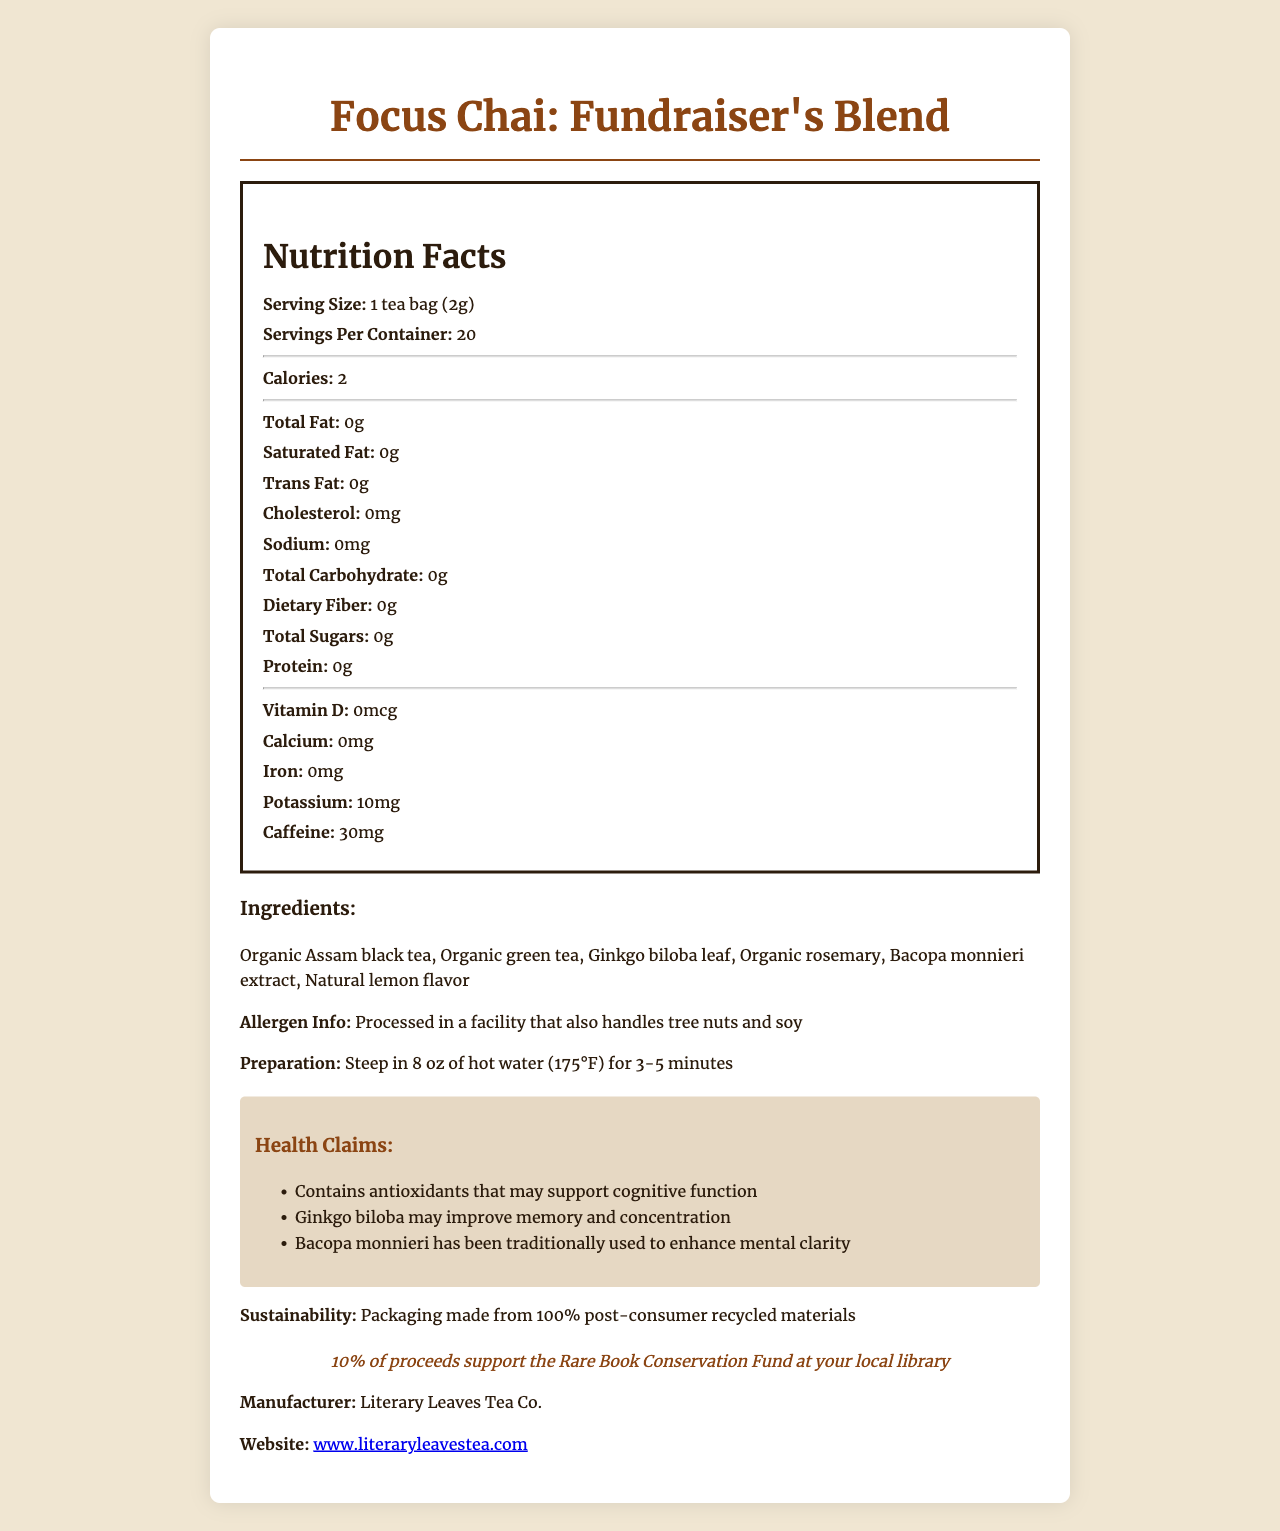what is the serving size for the Focus Chai: Fundraiser's Blend? The serving size is listed as "1 tea bag (2g)" in the document.
Answer: 1 tea bag (2g) how many servings are there per container? The document states that there are 20 servings per container.
Answer: 20 what is the amount of caffeine in each serving of this tea blend? The caffeine content per serving is listed as 30 mg.
Answer: 30 mg list two health claims made about the Focus Chai: Fundraiser's Blend. The document has a section titled "Health Claims" that includes these two statements.
Answer: Contains antioxidants that may support cognitive function; Ginkgo biloba may improve memory and concentration which ingredient is NOT in the Focus Chai: Fundraiser's Blend? A. Organic green tea B. Bacopa monnieri extract C. Chamomile The ingredients list in the document includes Organic green tea and Bacopa monnieri extract, but not Chamomile.
Answer: C. Chamomile where is the tea processed? The allergen information section specifies that the tea is processed in such a facility.
Answer: In a facility that also handles tree nuts and soy what is a key sustainability feature of this product? The sustainability information states this feature.
Answer: Packaging made from 100% post-consumer recycled materials which company manufactures the Focus Chai: Fundraiser's Blend? A. Literary Leaves Tea Co. B. Bookworms Tea Works C. Tea for Thought The manufacturer is listed as Literary Leaves Tea Co.
Answer: A. Literary Leaves Tea Co. does this tea contain any protein? The nutrition facts indicate that the amount of protein is 0 grams.
Answer: No how does ginkgo biloba contribute to the benefits of the Focus Chai: Fundraiser's Blend? The health claims include that Ginkgo biloba may improve memory and concentration.
Answer: May improve memory and concentration how should you prepare this tea? The preparation instructions specify how to steep the tea.
Answer: Steep in 8 oz of hot water (175°F) for 3-5 minutes what percentage of proceeds supports the Rare Book Conservation Fund? The fundraising note states that 10% of proceeds go to the Rare Book Conservation Fund.
Answer: 10% summarize the main details about the Focus Chai: Fundraiser's Blend. This summary covers the key aspects of the document, including ingredients, health benefits, sustainability, and the purpose of raising funds.
Answer: Focus Chai: Fundraiser's Blend is a specialty tea designed to promote focus and is made from a blend of Organic Assam black tea, Organic green tea, Ginkgo biloba leaf, Organic rosemary, Bacopa monnieri extract, and Natural lemon flavor. It contains 30 mg of caffeine per serving and has numerous health benefits such as improving cognitive function and memory. The tea is packaged sustainably and 10% of proceeds support the Rare Book Conservation Fund. It is manufactured by Literary Leaves Tea Co. how many grams of saturated fat are in the tea? The nutrition facts list the amount of saturated fat as 0 grams.
Answer: 0 grams does the document provide information on how the tea impacts blood sugar levels? The document does not include any specific information about the tea's impact on blood sugar levels.
Answer: Not enough information 